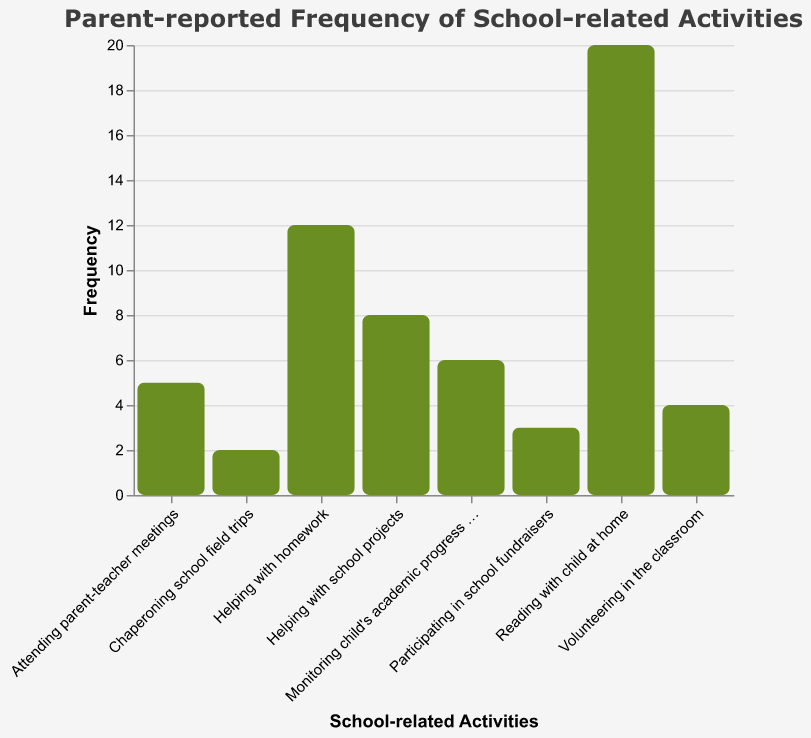What is the title of the figure? The title of the figure is arranged at the top and usually provides a concise summary of what the figure is about. Here it reads, "Parent-reported Frequency of School-related Activities".
Answer: Parent-reported Frequency of School-related Activities How many parent-reported activities are displayed in the figure? By counting the distinct bars, each representing a different activity, we find there are 8 parent-reported activities displayed.
Answer: 8 Which activity has the highest reported frequency? The bar representing "Reading with child at home" is tallest, indicating it has the highest frequency at 20.
Answer: Reading with child at home What is the frequency of "Volunteering in the classroom"? Look for the bar labeled "Volunteering in the classroom", then refer to its height or tooltip value which shows the frequency as 4.
Answer: 4 Which activities have a frequency lower than 5? By comparing the heights of bars to the y-axis, we find that "Attending parent-teacher meetings" (5), "Participating in school fundraisers" (3), and "Chaperoning school field trips" (2) are lower than 5.
Answer: Participating in school fundraisers, Chaperoning school field trips What is the combined frequency of "Helping with homework" and "Helping with school projects"? Add the reported frequencies of "Helping with homework" (12) and "Helping with school projects" (8), resulting in a combined total of 20.
Answer: 20 Which activity shows exactly half the frequency of "Reading with child at home"? "Reading with child at home" has a frequency of 20. Looking for half of this value (10), we see "Helping with homework" with a frequency of 12 is not exactly half. No activity shows exactly half the frequency.
Answer: None What is the average frequency of all activities reported? Sum all activity frequencies: (12 + 5 + 3 + 4 + 2 + 20 + 8 + 6) = 60. Then divide by the number of activities (8) to get the average: 60 ÷ 8 = 7.5.
Answer: 7.5 Which activity has a frequency closest to the average frequency? The average frequency is 7.5. Activities with frequencies close to 7.5 are "Helping with school projects" (8) and "Monitoring child's academic progress online" (6).
Answer: Helping with school projects 